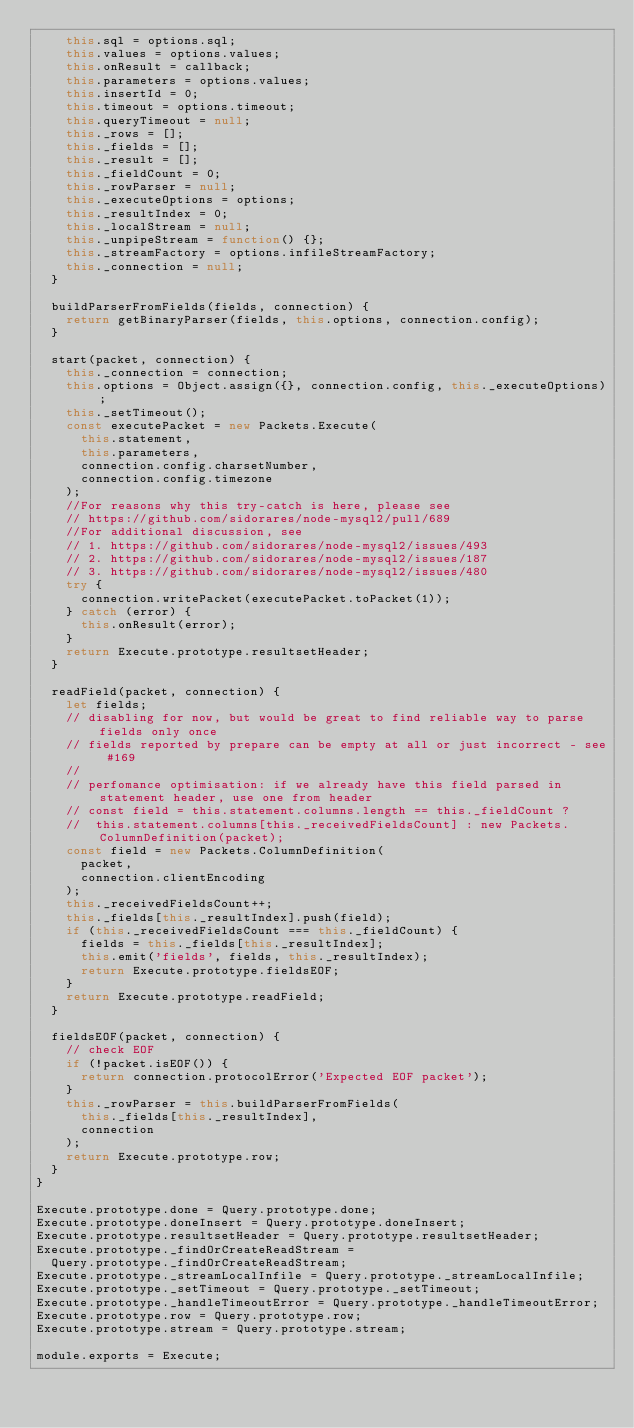Convert code to text. <code><loc_0><loc_0><loc_500><loc_500><_JavaScript_>    this.sql = options.sql;
    this.values = options.values;
    this.onResult = callback;
    this.parameters = options.values;
    this.insertId = 0;
    this.timeout = options.timeout;
    this.queryTimeout = null;
    this._rows = [];
    this._fields = [];
    this._result = [];
    this._fieldCount = 0;
    this._rowParser = null;
    this._executeOptions = options;
    this._resultIndex = 0;
    this._localStream = null;
    this._unpipeStream = function() {};
    this._streamFactory = options.infileStreamFactory;
    this._connection = null;
  }

  buildParserFromFields(fields, connection) {
    return getBinaryParser(fields, this.options, connection.config);
  }

  start(packet, connection) {
    this._connection = connection;
    this.options = Object.assign({}, connection.config, this._executeOptions);
    this._setTimeout();
    const executePacket = new Packets.Execute(
      this.statement,
      this.parameters,
      connection.config.charsetNumber,
      connection.config.timezone
    );
    //For reasons why this try-catch is here, please see
    // https://github.com/sidorares/node-mysql2/pull/689
    //For additional discussion, see
    // 1. https://github.com/sidorares/node-mysql2/issues/493
    // 2. https://github.com/sidorares/node-mysql2/issues/187
    // 3. https://github.com/sidorares/node-mysql2/issues/480
    try {
      connection.writePacket(executePacket.toPacket(1));
    } catch (error) {
      this.onResult(error);
    }
    return Execute.prototype.resultsetHeader;
  }

  readField(packet, connection) {
    let fields;
    // disabling for now, but would be great to find reliable way to parse fields only once
    // fields reported by prepare can be empty at all or just incorrect - see #169
    //
    // perfomance optimisation: if we already have this field parsed in statement header, use one from header
    // const field = this.statement.columns.length == this._fieldCount ?
    //  this.statement.columns[this._receivedFieldsCount] : new Packets.ColumnDefinition(packet);
    const field = new Packets.ColumnDefinition(
      packet,
      connection.clientEncoding
    );
    this._receivedFieldsCount++;
    this._fields[this._resultIndex].push(field);
    if (this._receivedFieldsCount === this._fieldCount) {
      fields = this._fields[this._resultIndex];
      this.emit('fields', fields, this._resultIndex);
      return Execute.prototype.fieldsEOF;
    }
    return Execute.prototype.readField;
  }

  fieldsEOF(packet, connection) {
    // check EOF
    if (!packet.isEOF()) {
      return connection.protocolError('Expected EOF packet');
    }
    this._rowParser = this.buildParserFromFields(
      this._fields[this._resultIndex],
      connection
    );
    return Execute.prototype.row;
  }
}

Execute.prototype.done = Query.prototype.done;
Execute.prototype.doneInsert = Query.prototype.doneInsert;
Execute.prototype.resultsetHeader = Query.prototype.resultsetHeader;
Execute.prototype._findOrCreateReadStream =
  Query.prototype._findOrCreateReadStream;
Execute.prototype._streamLocalInfile = Query.prototype._streamLocalInfile;
Execute.prototype._setTimeout = Query.prototype._setTimeout;
Execute.prototype._handleTimeoutError = Query.prototype._handleTimeoutError;
Execute.prototype.row = Query.prototype.row;
Execute.prototype.stream = Query.prototype.stream;

module.exports = Execute;
</code> 